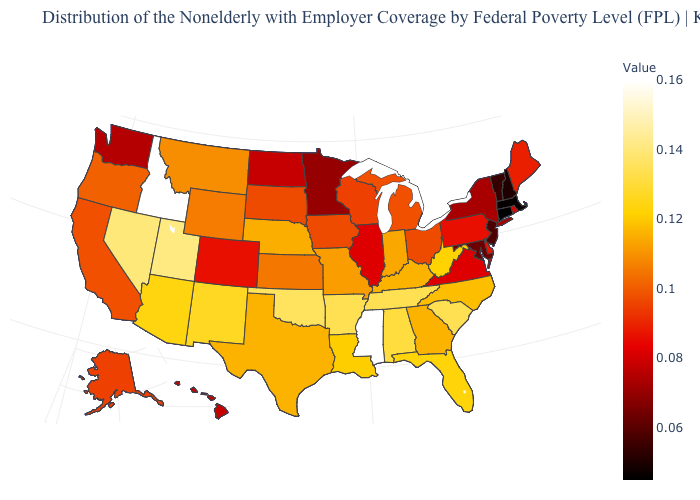Which states have the lowest value in the USA?
Write a very short answer. Connecticut. Which states hav the highest value in the South?
Keep it brief. Mississippi. Does Mississippi have the lowest value in the South?
Keep it brief. No. Which states hav the highest value in the Northeast?
Keep it brief. Maine. Which states hav the highest value in the MidWest?
Write a very short answer. Nebraska. Among the states that border Washington , which have the lowest value?
Short answer required. Oregon. Does Nebraska have the lowest value in the USA?
Concise answer only. No. 